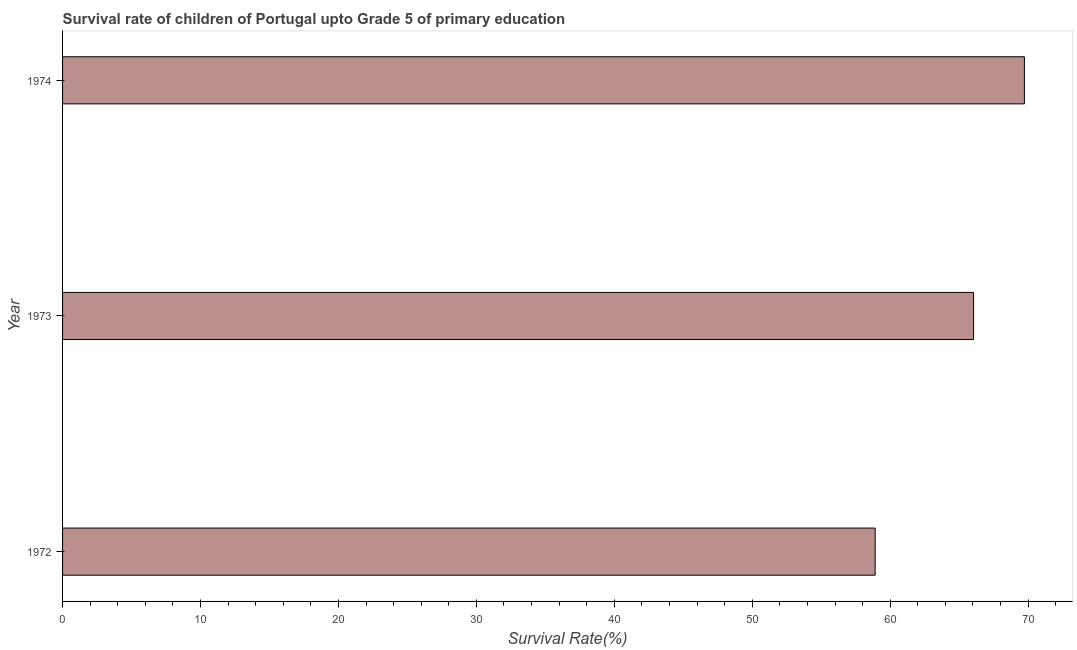Does the graph contain grids?
Provide a short and direct response. No. What is the title of the graph?
Offer a terse response. Survival rate of children of Portugal upto Grade 5 of primary education. What is the label or title of the X-axis?
Keep it short and to the point. Survival Rate(%). What is the survival rate in 1974?
Provide a succinct answer. 69.73. Across all years, what is the maximum survival rate?
Keep it short and to the point. 69.73. Across all years, what is the minimum survival rate?
Ensure brevity in your answer.  58.91. In which year was the survival rate maximum?
Your answer should be very brief. 1974. What is the sum of the survival rate?
Offer a terse response. 194.69. What is the difference between the survival rate in 1973 and 1974?
Provide a short and direct response. -3.69. What is the average survival rate per year?
Your answer should be compact. 64.9. What is the median survival rate?
Your answer should be very brief. 66.05. What is the ratio of the survival rate in 1972 to that in 1973?
Your response must be concise. 0.89. Is the survival rate in 1972 less than that in 1973?
Provide a short and direct response. Yes. Is the difference between the survival rate in 1973 and 1974 greater than the difference between any two years?
Provide a short and direct response. No. What is the difference between the highest and the second highest survival rate?
Your answer should be compact. 3.69. Is the sum of the survival rate in 1972 and 1974 greater than the maximum survival rate across all years?
Keep it short and to the point. Yes. What is the difference between the highest and the lowest survival rate?
Your answer should be very brief. 10.82. In how many years, is the survival rate greater than the average survival rate taken over all years?
Provide a short and direct response. 2. What is the difference between two consecutive major ticks on the X-axis?
Offer a very short reply. 10. What is the Survival Rate(%) in 1972?
Your answer should be compact. 58.91. What is the Survival Rate(%) in 1973?
Make the answer very short. 66.05. What is the Survival Rate(%) in 1974?
Your answer should be compact. 69.73. What is the difference between the Survival Rate(%) in 1972 and 1973?
Offer a terse response. -7.14. What is the difference between the Survival Rate(%) in 1972 and 1974?
Your response must be concise. -10.82. What is the difference between the Survival Rate(%) in 1973 and 1974?
Your answer should be compact. -3.68. What is the ratio of the Survival Rate(%) in 1972 to that in 1973?
Offer a terse response. 0.89. What is the ratio of the Survival Rate(%) in 1972 to that in 1974?
Ensure brevity in your answer.  0.84. What is the ratio of the Survival Rate(%) in 1973 to that in 1974?
Give a very brief answer. 0.95. 